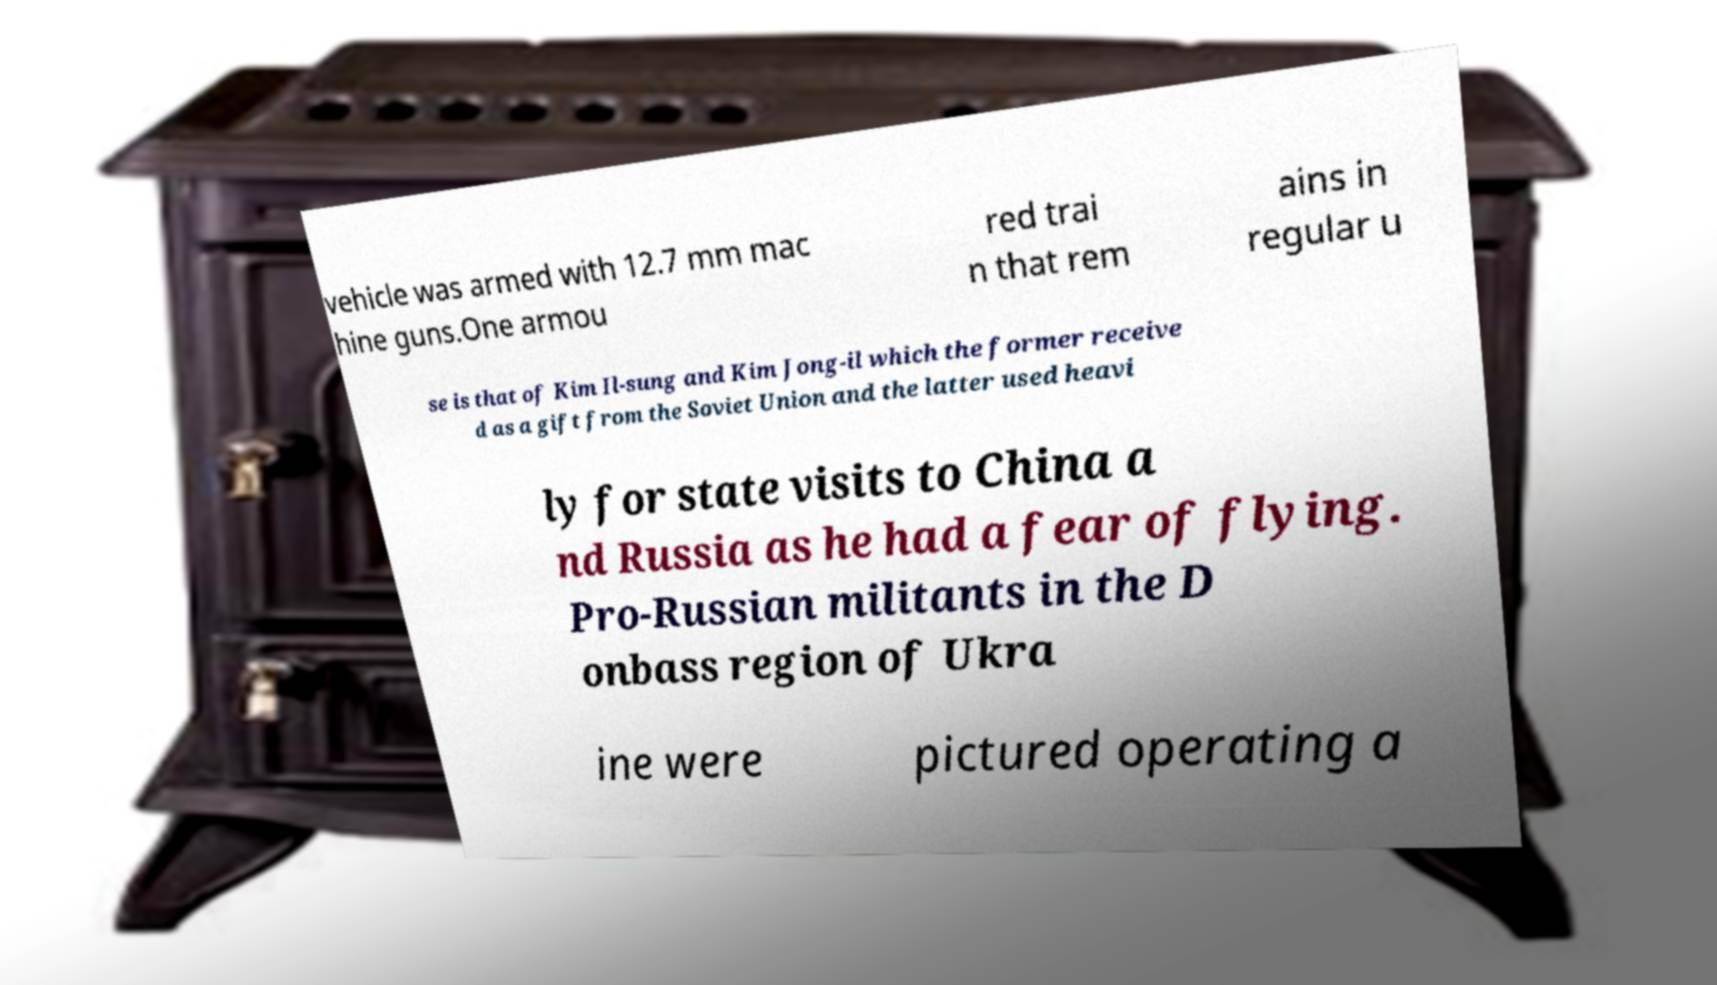Could you assist in decoding the text presented in this image and type it out clearly? vehicle was armed with 12.7 mm mac hine guns.One armou red trai n that rem ains in regular u se is that of Kim Il-sung and Kim Jong-il which the former receive d as a gift from the Soviet Union and the latter used heavi ly for state visits to China a nd Russia as he had a fear of flying. Pro-Russian militants in the D onbass region of Ukra ine were pictured operating a 